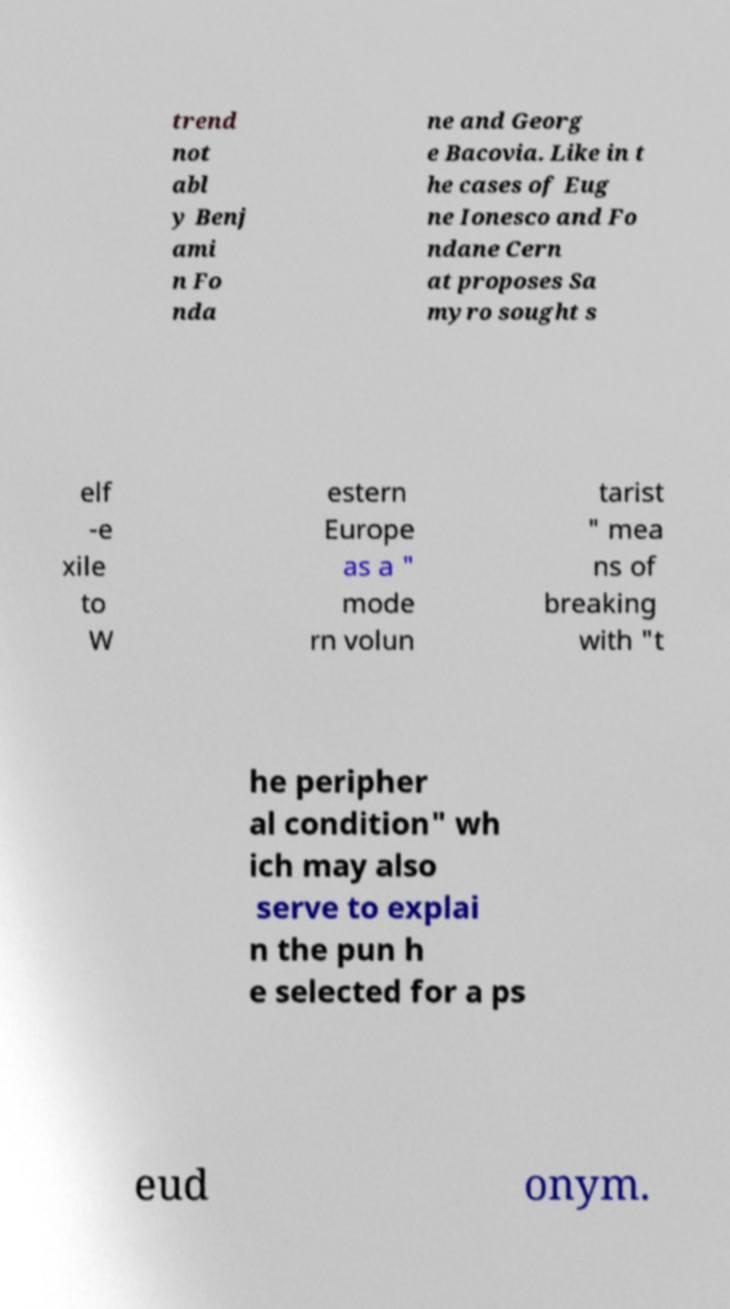Could you extract and type out the text from this image? trend not abl y Benj ami n Fo nda ne and Georg e Bacovia. Like in t he cases of Eug ne Ionesco and Fo ndane Cern at proposes Sa myro sought s elf -e xile to W estern Europe as a " mode rn volun tarist " mea ns of breaking with "t he peripher al condition" wh ich may also serve to explai n the pun h e selected for a ps eud onym. 